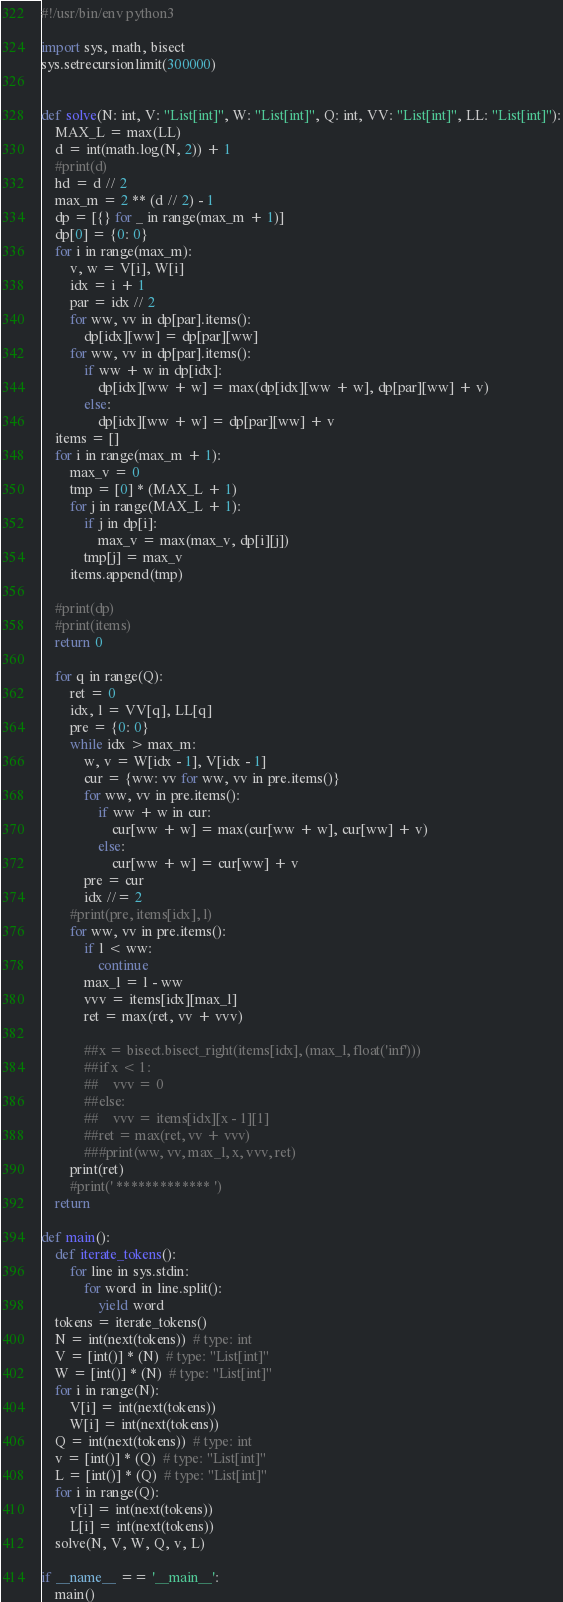Convert code to text. <code><loc_0><loc_0><loc_500><loc_500><_Python_>#!/usr/bin/env python3

import sys, math, bisect
sys.setrecursionlimit(300000)


def solve(N: int, V: "List[int]", W: "List[int]", Q: int, VV: "List[int]", LL: "List[int]"):
    MAX_L = max(LL)
    d = int(math.log(N, 2)) + 1
    #print(d)
    hd = d // 2
    max_m = 2 ** (d // 2) - 1
    dp = [{} for _ in range(max_m + 1)]
    dp[0] = {0: 0}
    for i in range(max_m):
        v, w = V[i], W[i]
        idx = i + 1
        par = idx // 2
        for ww, vv in dp[par].items():
            dp[idx][ww] = dp[par][ww]
        for ww, vv in dp[par].items():
            if ww + w in dp[idx]:
                dp[idx][ww + w] = max(dp[idx][ww + w], dp[par][ww] + v)
            else:
                dp[idx][ww + w] = dp[par][ww] + v
    items = []
    for i in range(max_m + 1):
        max_v = 0
        tmp = [0] * (MAX_L + 1)
        for j in range(MAX_L + 1):
            if j in dp[i]:
                max_v = max(max_v, dp[i][j])
            tmp[j] = max_v
        items.append(tmp)

    #print(dp)
    #print(items)
    return 0

    for q in range(Q):
        ret = 0
        idx, l = VV[q], LL[q]
        pre = {0: 0}
        while idx > max_m:
            w, v = W[idx - 1], V[idx - 1]
            cur = {ww: vv for ww, vv in pre.items()}
            for ww, vv in pre.items():
                if ww + w in cur:
                    cur[ww + w] = max(cur[ww + w], cur[ww] + v)
                else:
                    cur[ww + w] = cur[ww] + v
            pre = cur
            idx //= 2
        #print(pre, items[idx], l)
        for ww, vv in pre.items():
            if l < ww:
                continue
            max_l = l - ww
            vvv = items[idx][max_l]
            ret = max(ret, vv + vvv)

            ##x = bisect.bisect_right(items[idx], (max_l, float('inf')))
            ##if x < 1:
            ##    vvv = 0
            ##else:
            ##    vvv = items[idx][x - 1][1]
            ##ret = max(ret, vv + vvv)
            ###print(ww, vv, max_l, x, vvv, ret)
        print(ret)
        #print(' ************* ')
    return

def main():
    def iterate_tokens():
        for line in sys.stdin:
            for word in line.split():
                yield word
    tokens = iterate_tokens()
    N = int(next(tokens))  # type: int
    V = [int()] * (N)  # type: "List[int]"
    W = [int()] * (N)  # type: "List[int]"
    for i in range(N):
        V[i] = int(next(tokens))
        W[i] = int(next(tokens))
    Q = int(next(tokens))  # type: int
    v = [int()] * (Q)  # type: "List[int]"
    L = [int()] * (Q)  # type: "List[int]"
    for i in range(Q):
        v[i] = int(next(tokens))
        L[i] = int(next(tokens))
    solve(N, V, W, Q, v, L)

if __name__ == '__main__':
    main()
</code> 